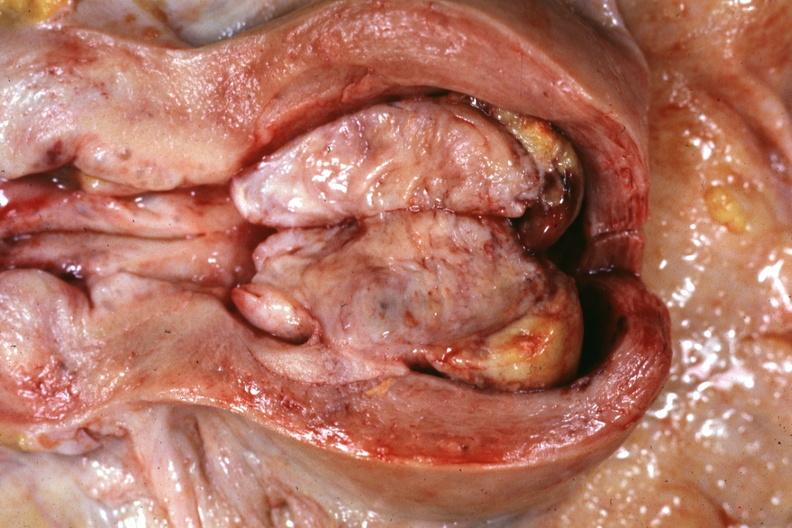what does this image show?
Answer the question using a single word or phrase. Opened uterus with cut surface of tumor shown very good 